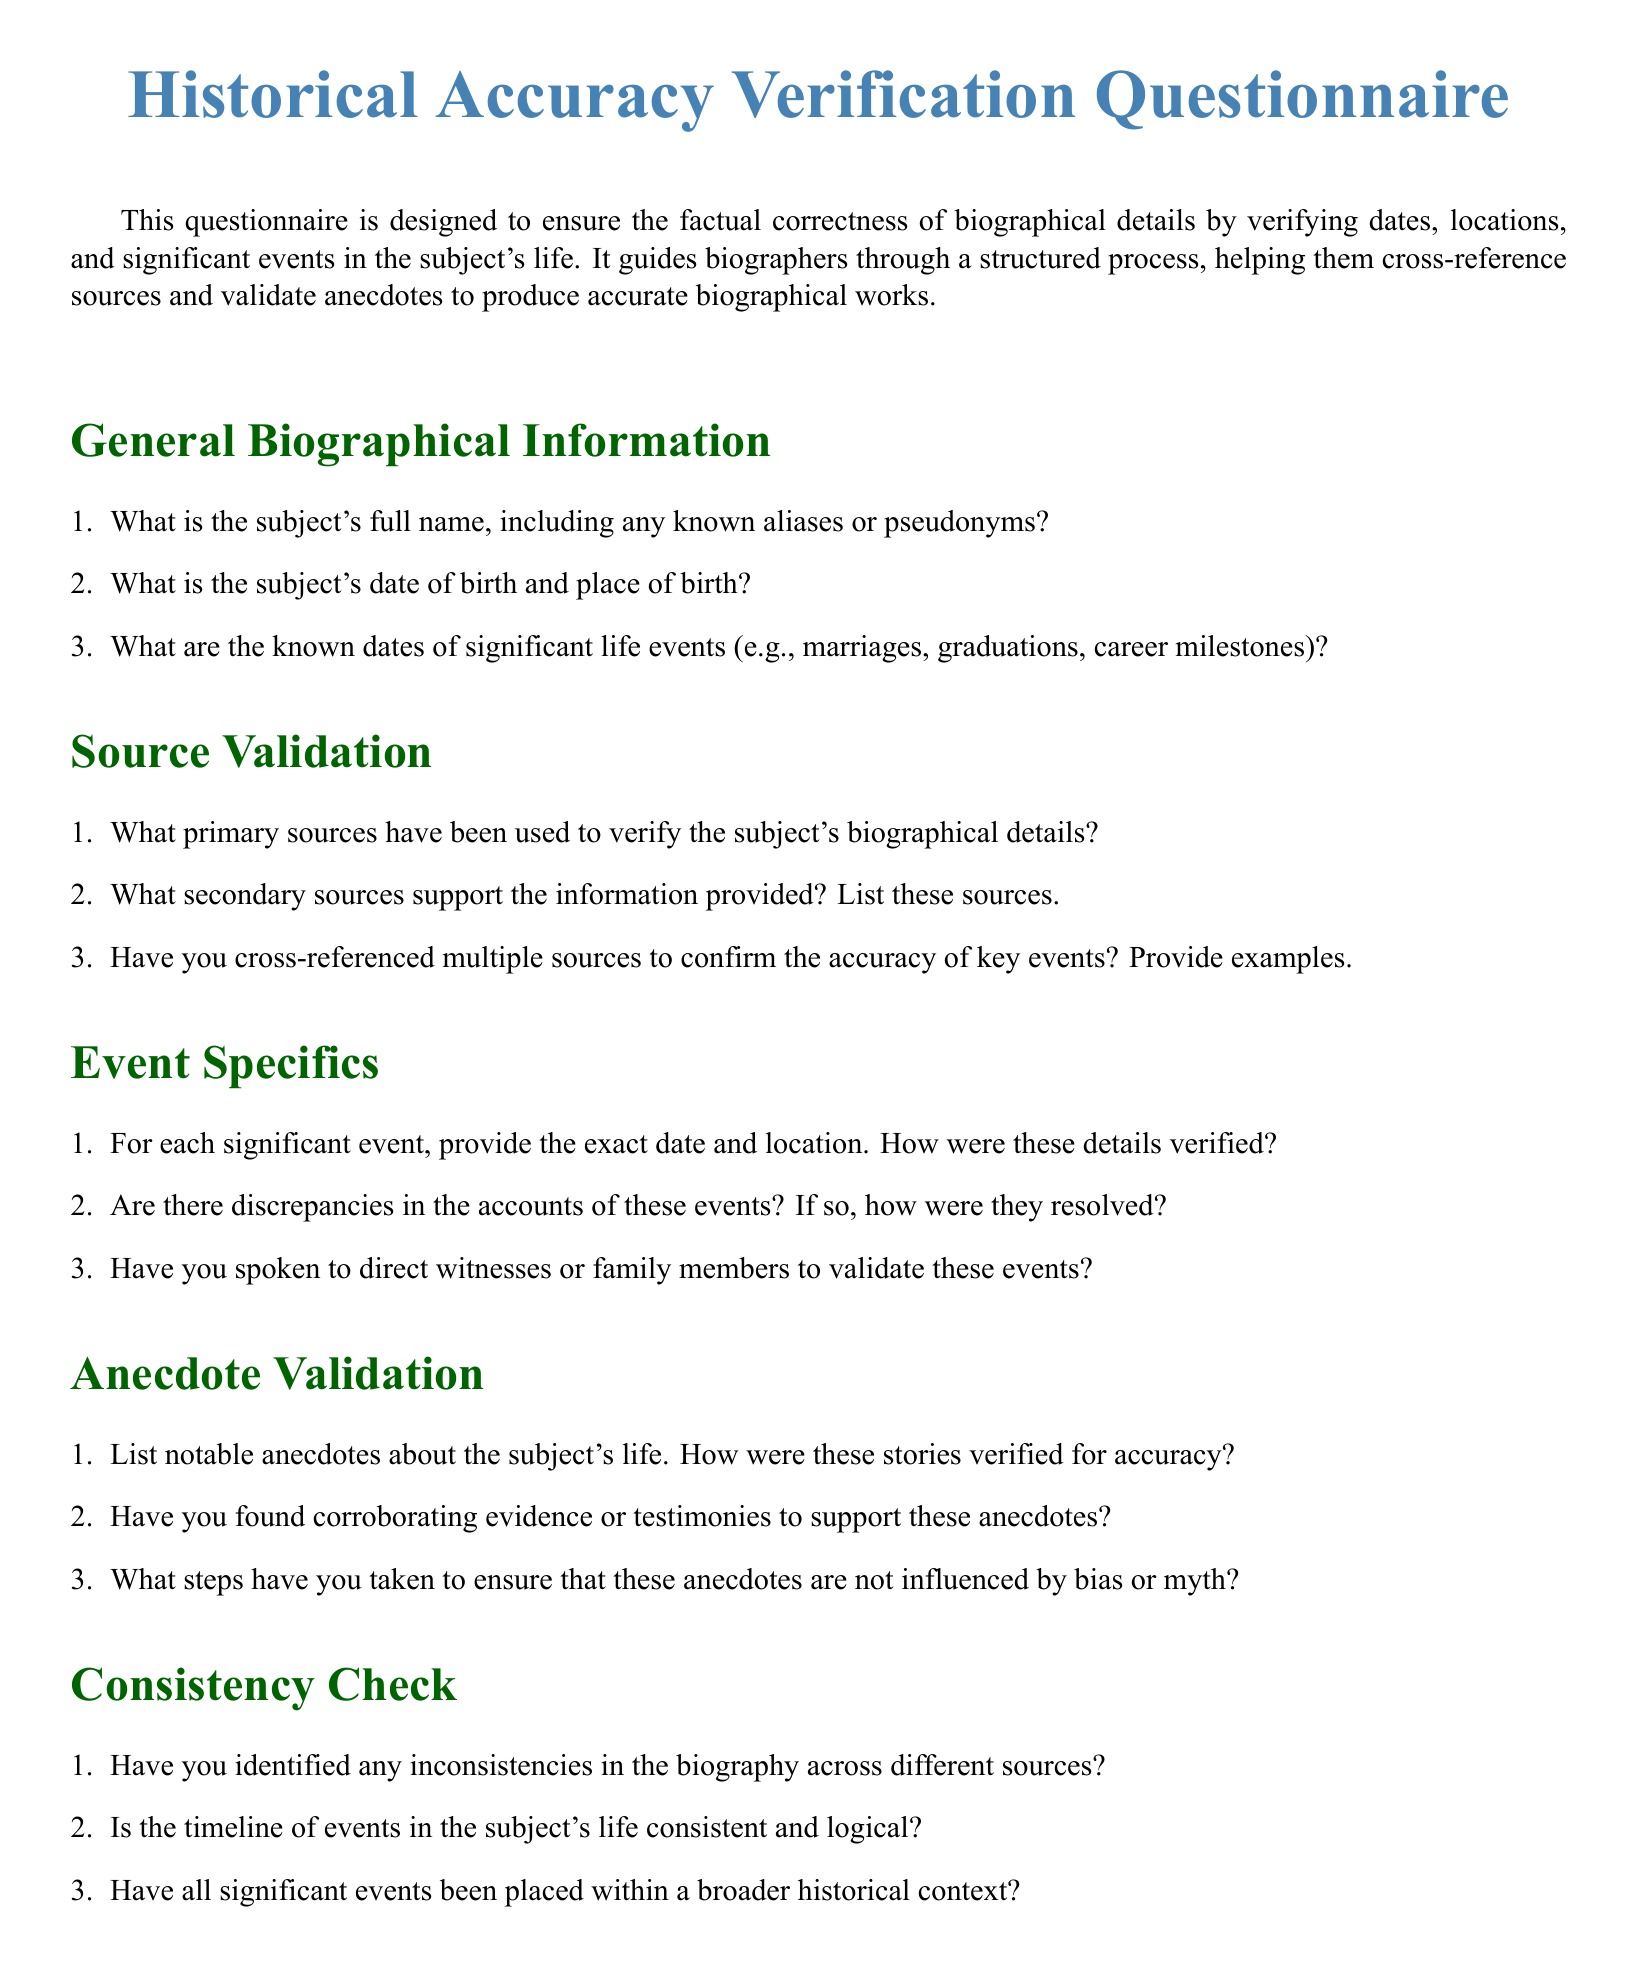What is the subject's full name? This question asks for specific information regarding the subject's name as indicated in the 'General Biographical Information' section.
Answer: Subject's full name What is the date of birth? The question seeks the date of birth found in the 'General Biographical Information' section.
Answer: Date of birth What sources support the information provided? This question requires identification of secondary sources listed in the 'Source Validation' section.
Answer: Secondary sources What are the three types of questions included in this document? This question asks for the types of questions, which are outlined in the introduction of the document, specifically focusing on various aspects of accuracy verification.
Answer: Information retrieval, reasoning, document type-specific How are significant events verified? This question seeks the method of verification as indicated in the 'Event Specifics' section, particularly how details are confirmed.
Answer: Cross-referencing sources Have inconsistencies been identified? The question looks for a yes or no answer based on the 'Consistency Check' section regarding inconsistencies in different sources.
Answer: Yes/No What color is used for section headings? This question inquires about the design aspect mentioned in the document's preamble, specifically referring to visual elements.
Answer: Green How many sections are in the questionnaire? This question seeks a numerical count of the sections present within the document.
Answer: Six What is the main purpose of the questionnaire? This question is asking for a concise description of the document's intent as mentioned in the introductory paragraph.
Answer: Verify factual correctness 